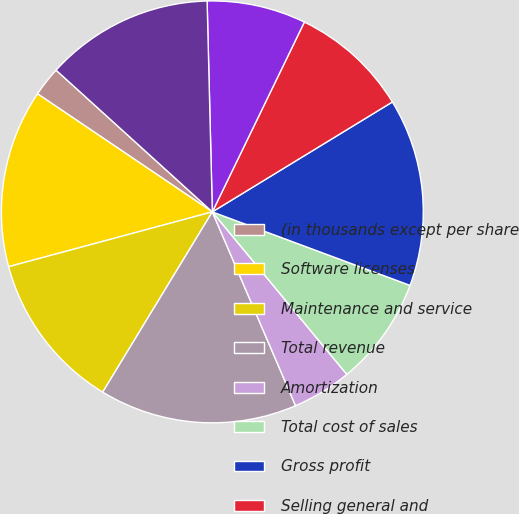Convert chart to OTSL. <chart><loc_0><loc_0><loc_500><loc_500><pie_chart><fcel>(in thousands except per share<fcel>Software licenses<fcel>Maintenance and service<fcel>Total revenue<fcel>Amortization<fcel>Total cost of sales<fcel>Gross profit<fcel>Selling general and<fcel>Research and development<fcel>Total operating expenses<nl><fcel>2.27%<fcel>13.64%<fcel>12.12%<fcel>15.15%<fcel>4.55%<fcel>8.33%<fcel>14.39%<fcel>9.09%<fcel>7.58%<fcel>12.88%<nl></chart> 